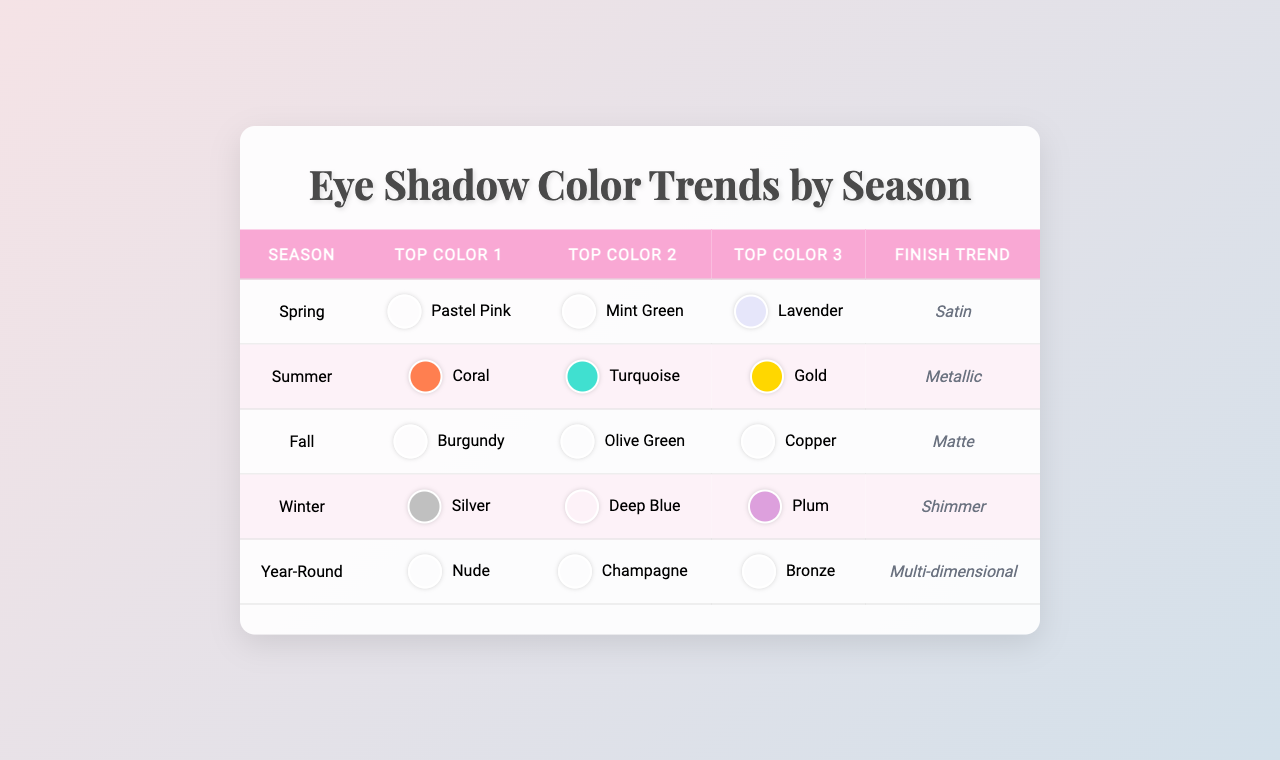What's the top color for Spring? According to the table, the first color listed for Spring is Pastel Pink.
Answer: Pastel Pink Which finish trend is associated with Summer? The table shows that the finish trend for Summer is Metallic.
Answer: Metallic Is Burgundy a top color for Fall? The table lists Burgundy as one of the top colors for Fall, confirming that it is included.
Answer: Yes What are the top colors for Winter? The table shows the top colors for Winter, which are Silver, Deep Blue, and Plum.
Answer: Silver, Deep Blue, Plum Which season features Multi-dimensional as the finish trend? Looking at the table, Multi-dimensional is the finish trend listed under Year-Round.
Answer: Year-Round How many distinct colors are listed for Fall? The table lists three colors for Fall: Burgundy, Olive Green, and Copper, making a total of three distinct colors.
Answer: 3 Which color appears most frequently across the seasons in the table? Analyzing the colors across all seasons, the table lists unique colors for each season without repetition, so there is no single color that appears most frequently.
Answer: None Are any colors repeated across seasons? After reviewing the table, each color listed for the different seasons is unique to that season; thus, no colors are repeated.
Answer: No What is the dominant finish trend for eye shadows throughout the year? The table indicates that the finish trend that appears for the year-round option is Multi-dimensional, which pertains to eye shadows throughout all seasons.
Answer: Multi-dimensional Which two colors follow Coral in the Summer season? According to the table, after Coral, the next two top colors for Summer are Turquoise and Gold.
Answer: Turquoise, Gold What is the difference in finish trends between Spring and Fall? The table states that Spring features a Satin finish trend, while Fall has a Matte finish trend, resulting in a distinction between these two finishes.
Answer: Satin vs Matte 